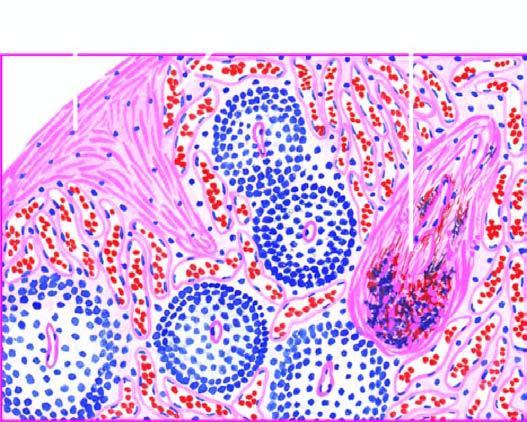what are dilated and congested?
Answer the question using a single word or phrase. The sinuses 